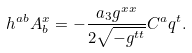Convert formula to latex. <formula><loc_0><loc_0><loc_500><loc_500>h ^ { a b } A _ { b } ^ { x } = - \frac { a _ { 3 } g ^ { x x } } { 2 \sqrt { - g ^ { t t } } } C ^ { a } q ^ { t } .</formula> 